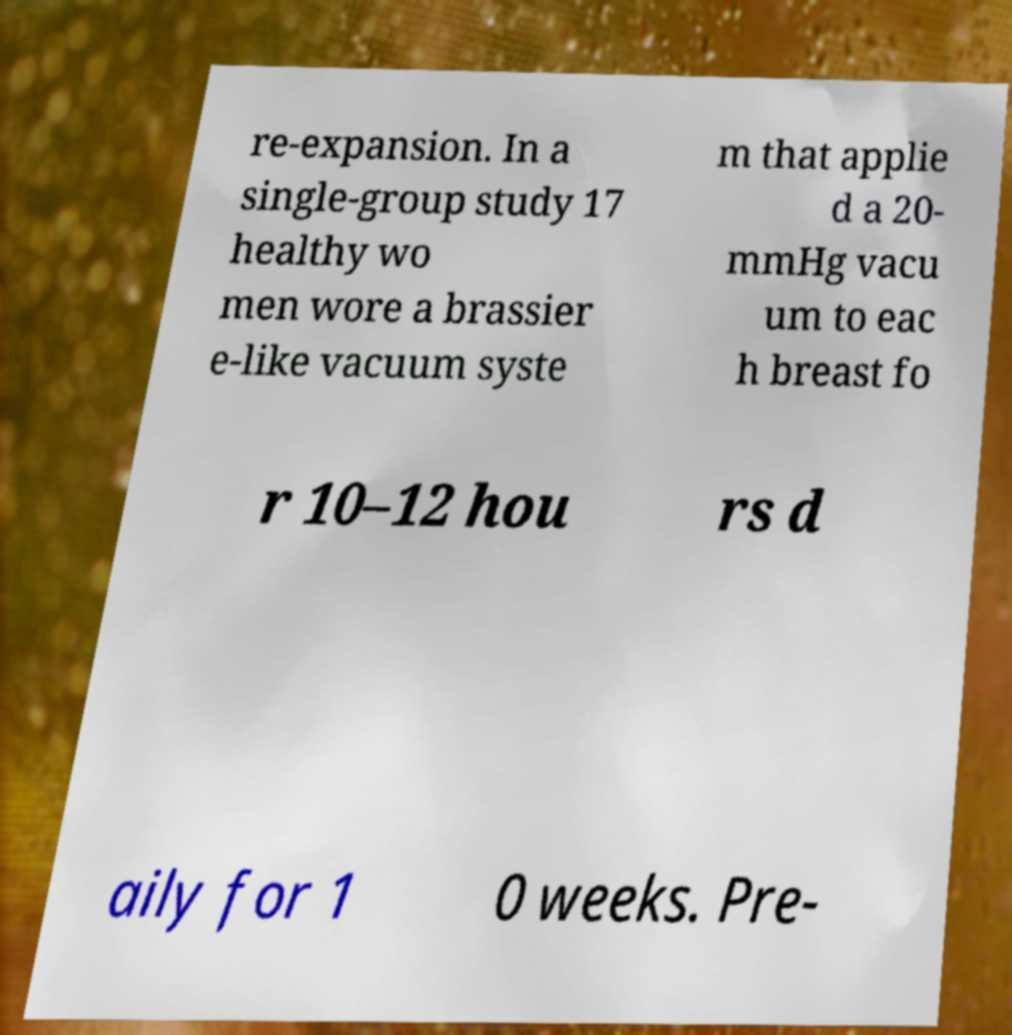What messages or text are displayed in this image? I need them in a readable, typed format. re-expansion. In a single-group study 17 healthy wo men wore a brassier e-like vacuum syste m that applie d a 20- mmHg vacu um to eac h breast fo r 10–12 hou rs d aily for 1 0 weeks. Pre- 